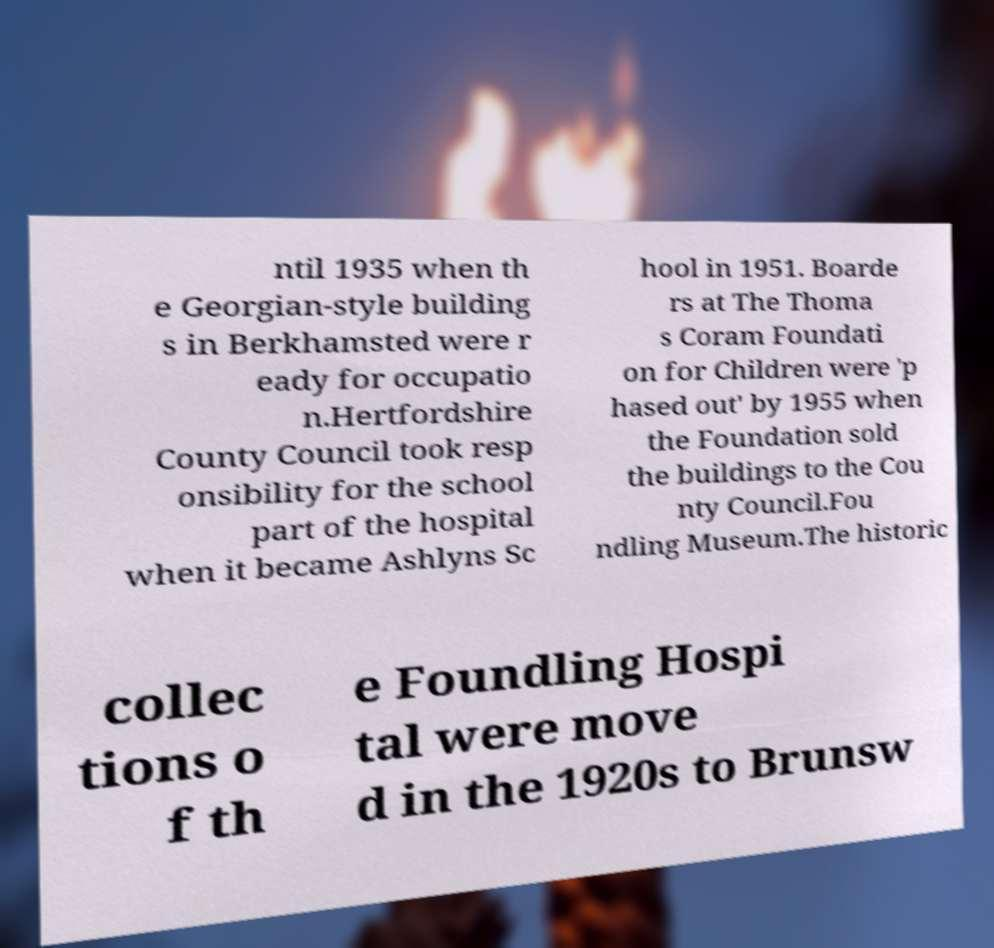What messages or text are displayed in this image? I need them in a readable, typed format. ntil 1935 when th e Georgian-style building s in Berkhamsted were r eady for occupatio n.Hertfordshire County Council took resp onsibility for the school part of the hospital when it became Ashlyns Sc hool in 1951. Boarde rs at The Thoma s Coram Foundati on for Children were 'p hased out' by 1955 when the Foundation sold the buildings to the Cou nty Council.Fou ndling Museum.The historic collec tions o f th e Foundling Hospi tal were move d in the 1920s to Brunsw 